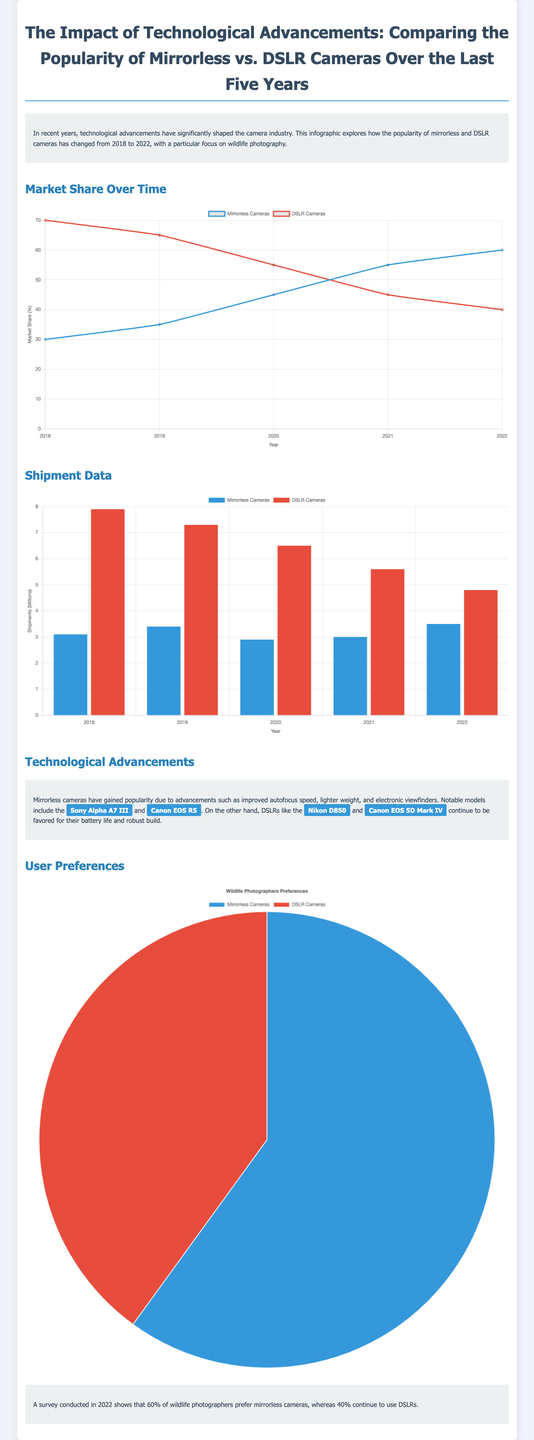What is the market share of mirrorless cameras in 2022? The market share of mirrorless cameras in 2022 is shown in the line graph, which indicates it reached 60%.
Answer: 60% What percentage of wildlife photographers prefer DSLR cameras? The document states that 40% of wildlife photographers continue to use DSLRs.
Answer: 40% Which camera model is highlighted as a notable mirrorless camera? The document specifically highlights the Sony Alpha A7 III as a notable mirrorless camera.
Answer: Sony Alpha A7 III How many shipments of DSLR cameras were recorded in 2020? The bar chart indicates that shipments of DSLR cameras in 2020 were 6.5 million.
Answer: 6.5 million What is the trend in market share for DSLR cameras from 2018 to 2022? The line graph shows a declining trend in the market share of DSLR cameras from 70% to 40%.
Answer: Declining Which year showed the highest shipments for mirrorless cameras? According to the bar chart, shipments for mirrorless cameras peaked at 3.5 million in 2022.
Answer: 3.5 million What color represents mirrorless cameras in the pie chart regarding user preferences? The pie chart uses blue to represent mirrorless cameras in user preferences.
Answer: Blue In which year did the market share of DSLR cameras drop below 50%? The line graph indicates that the market share of DSLR cameras fell below 50% in 2021.
Answer: 2021 